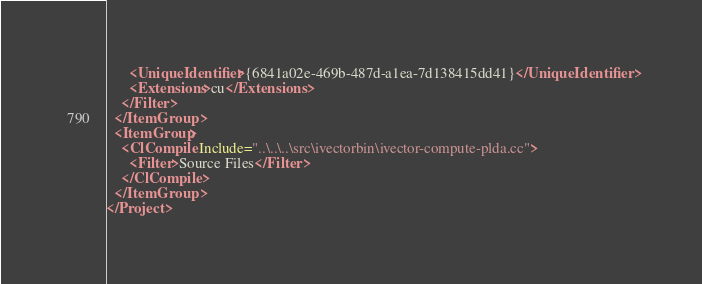<code> <loc_0><loc_0><loc_500><loc_500><_XML_>      <UniqueIdentifier>{6841a02e-469b-487d-a1ea-7d138415dd41}</UniqueIdentifier>
      <Extensions>cu</Extensions>
    </Filter>
  </ItemGroup>
  <ItemGroup>
    <ClCompile Include="..\..\..\src\ivectorbin\ivector-compute-plda.cc">
      <Filter>Source Files</Filter>
    </ClCompile>
  </ItemGroup>
</Project>
</code> 